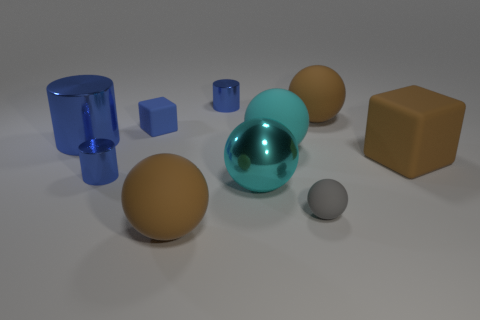Subtract all red balls. Subtract all cyan cubes. How many balls are left? 5 Subtract all cubes. How many objects are left? 8 Add 3 big brown balls. How many big brown balls are left? 5 Add 5 large brown blocks. How many large brown blocks exist? 6 Subtract 0 yellow cylinders. How many objects are left? 10 Subtract all big cyan rubber things. Subtract all big cyan cylinders. How many objects are left? 9 